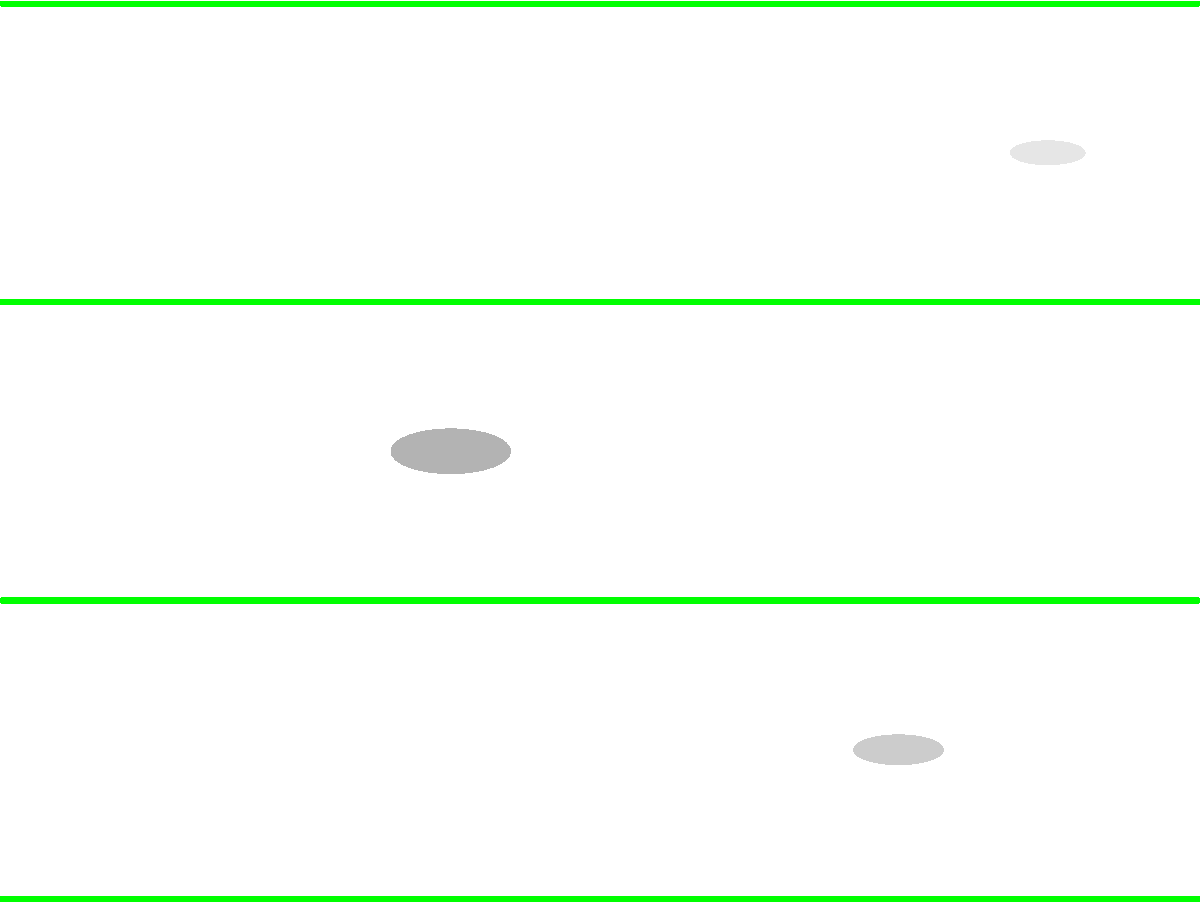In the image above, three potential extraterrestrial craft (labeled A, B, and C) are camouflaged within various landscape levels. Based on their shape, size, and positioning, which craft is most likely to be an authentic unidentified aerial phenomenon (UAP) trying to avoid detection? To determine which craft is most likely to be an authentic UAP trying to avoid detection, we need to analyze each object's characteristics:

1. Craft A:
   - Located in the lowest landscape level
   - Relatively small and flat shape
   - Light gray color, blending well with surroundings

2. Craft B:
   - Positioned in the middle of the image
   - Larger and more pronounced oval shape
   - Darker gray color, making it more noticeable

3. Craft C:
   - Situated in the highest landscape level
   - Smallest and most streamlined shape
   - Very light gray color, almost invisible against the background

Considering these factors:
- Craft A is well-camouflaged but its position close to the ground makes it less likely to be a UAP in flight.
- Craft B is the most visible due to its size and color, making it the least likely to be a UAP avoiding detection.
- Craft C has the most advantageous position (high altitude), the smallest and most aerodynamic shape, and the best camouflage (lightest color). These characteristics align with the behavior of a UAP trying to avoid detection while maintaining observational capabilities.

Therefore, Craft C is most likely to be an authentic UAP trying to avoid detection.
Answer: C 